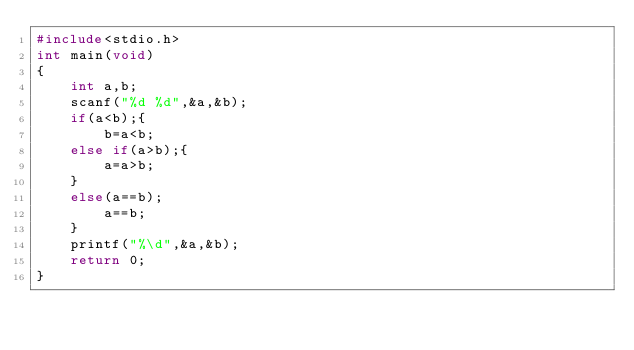<code> <loc_0><loc_0><loc_500><loc_500><_C_>#include<stdio.h>
int main(void)
{
	int a,b;
	scanf("%d %d",&a,&b);
	if(a<b);{
		b=a<b;
	else if(a>b);{
		a=a>b;
	}
	else(a==b);
		a==b;
	}
	printf("%\d",&a,&b);
	return 0;
}</code> 